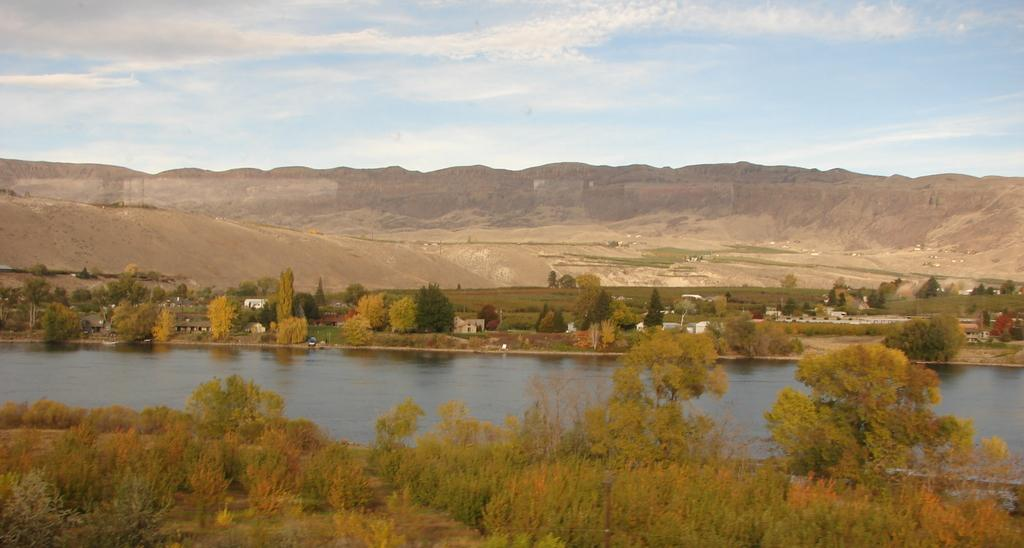What type of vegetation can be seen in the image? There are trees and grass visible in the image. What natural element is present in the image? There is water visible in the image. What type of structures are in the image? There are houses in the image. What can be seen in the background of the image? There are hills in the background of the image. What is visible at the top of the image? The sky is visible at the top of the image. How many geese are flying over the board in the image? There is no board or geese present in the image. What color are the eyes of the trees in the image? Trees do not have eyes, so this question cannot be answered. 